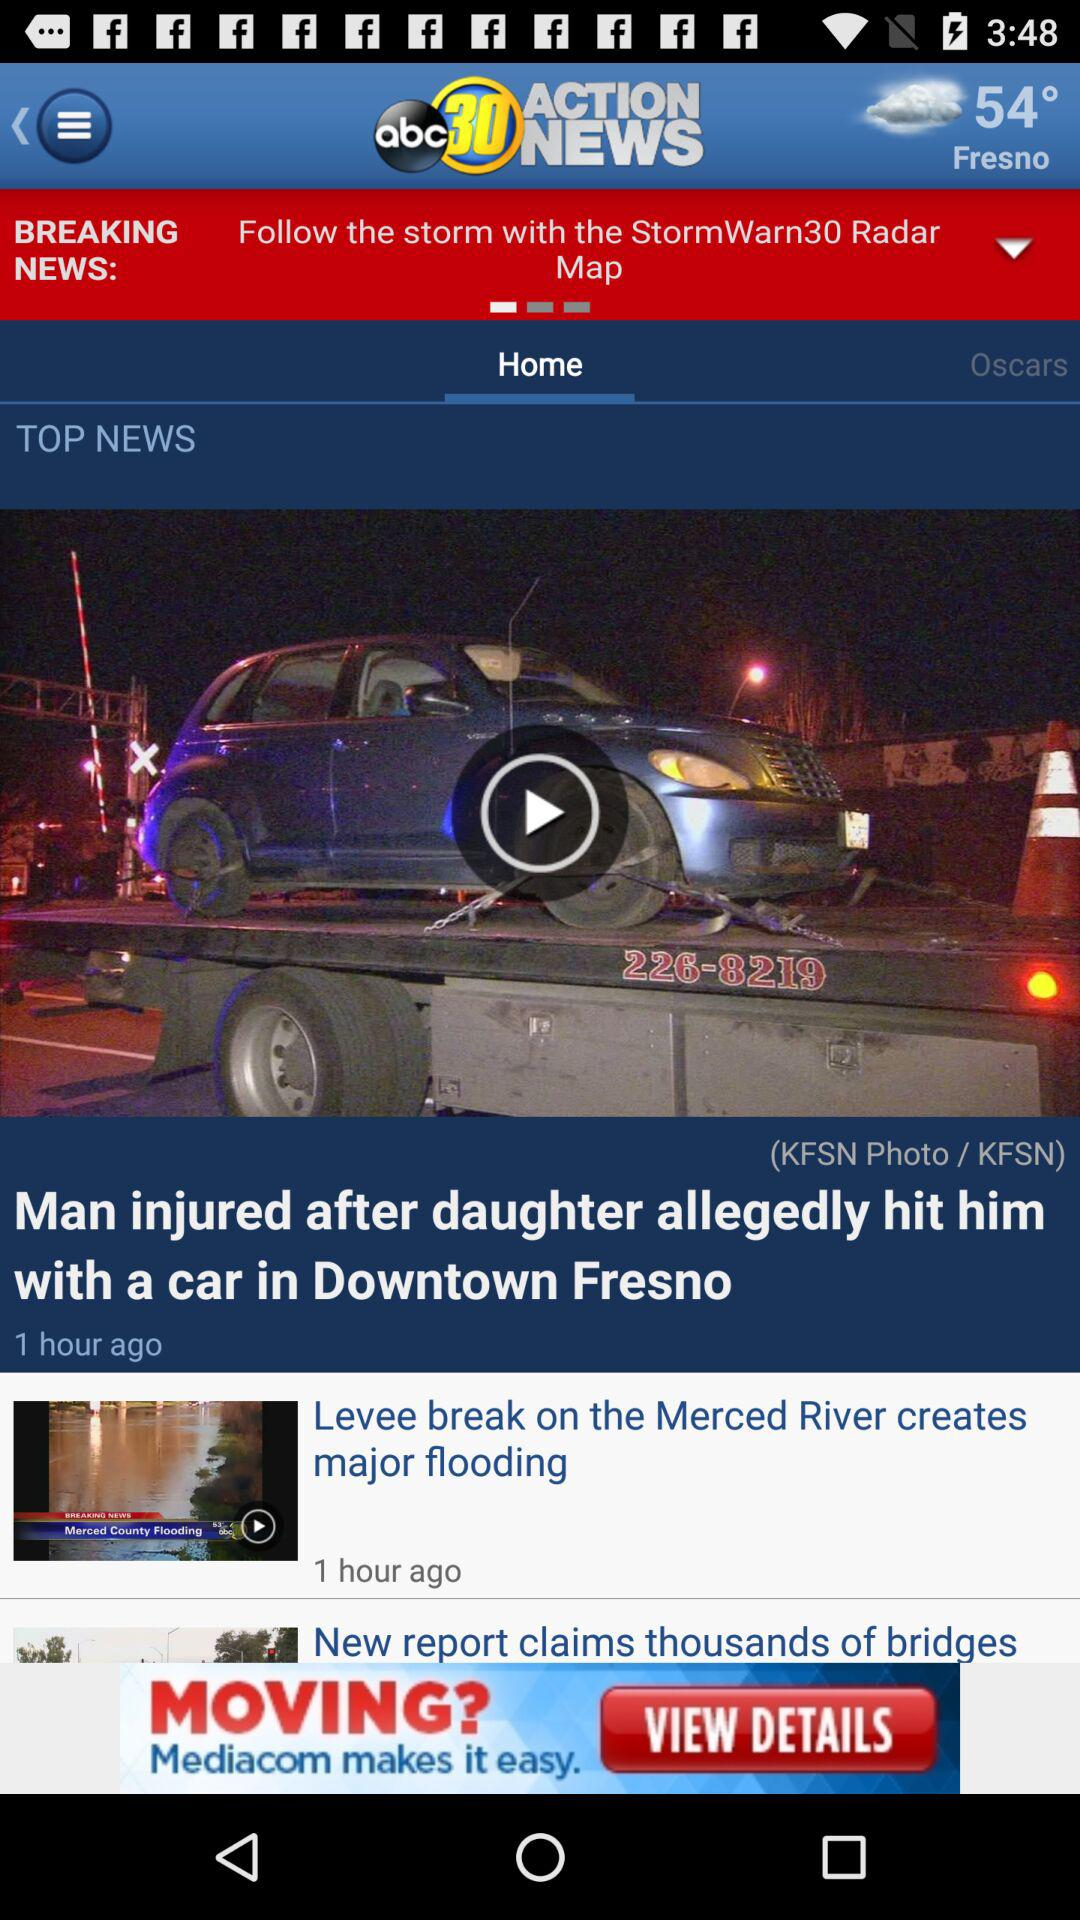What is the application name? The application name is "abc30 ACTION NEWS". 